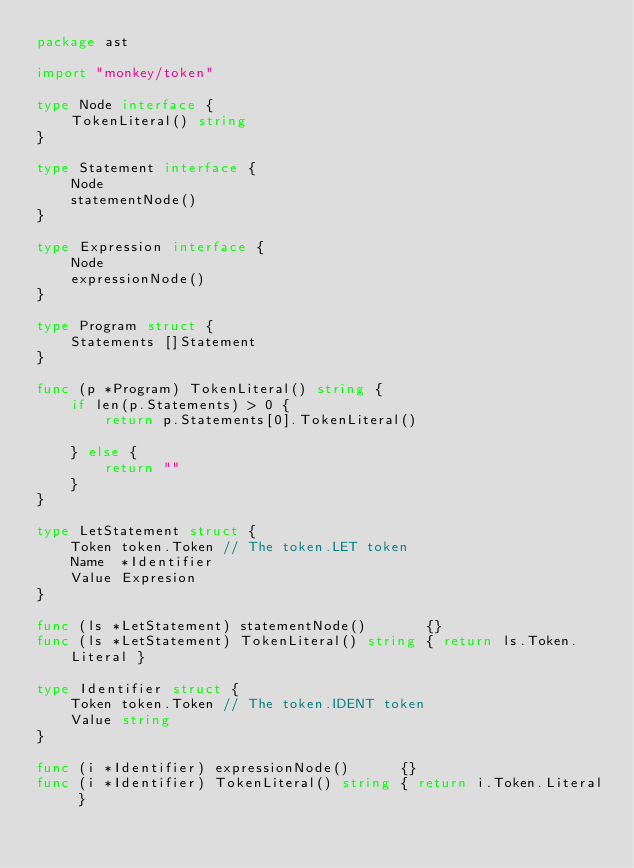<code> <loc_0><loc_0><loc_500><loc_500><_Go_>package ast

import "monkey/token"

type Node interface {
	TokenLiteral() string
}

type Statement interface {
	Node
	statementNode()
}

type Expression interface {
	Node
	expressionNode()
}

type Program struct {
	Statements []Statement
}

func (p *Program) TokenLiteral() string {
	if len(p.Statements) > 0 {
		return p.Statements[0].TokenLiteral()

	} else {
		return ""
	}
}

type LetStatement struct {
	Token token.Token // The token.LET token
	Name  *Identifier
	Value Expresion
}

func (ls *LetStatement) statementNode()       {}
func (ls *LetStatement) TokenLiteral() string { return ls.Token.Literal }

type Identifier struct {
	Token token.Token // The token.IDENT token
	Value string
}

func (i *Identifier) expressionNode()      {}
func (i *Identifier) TokenLiteral() string { return i.Token.Literal }
</code> 